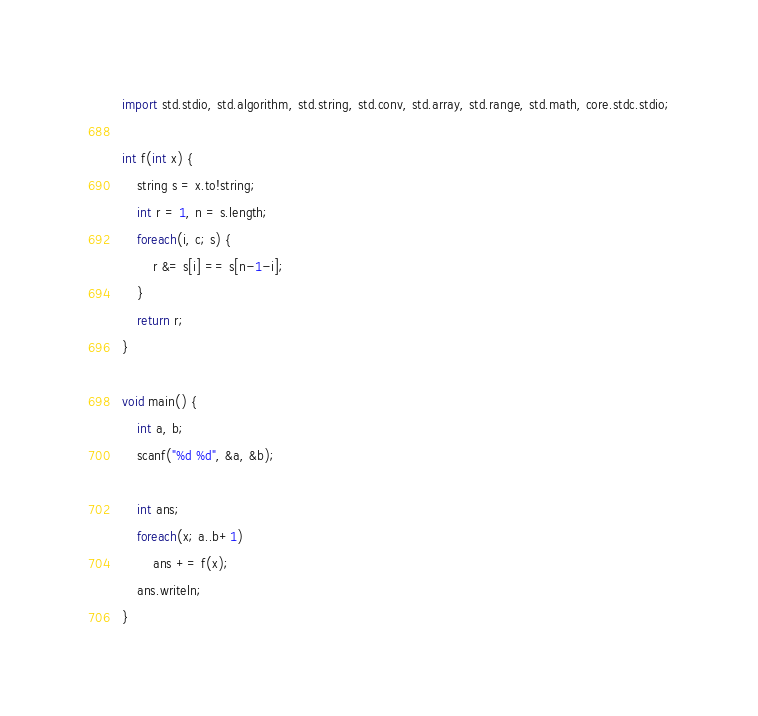Convert code to text. <code><loc_0><loc_0><loc_500><loc_500><_D_>import std.stdio, std.algorithm, std.string, std.conv, std.array, std.range, std.math, core.stdc.stdio;

int f(int x) {
    string s = x.to!string;
    int r = 1, n = s.length;
    foreach(i, c; s) {
        r &= s[i] == s[n-1-i];
    }
    return r;
}

void main() {
    int a, b;
    scanf("%d %d", &a, &b);

    int ans;
    foreach(x; a..b+1)
        ans += f(x);
    ans.writeln;
}</code> 